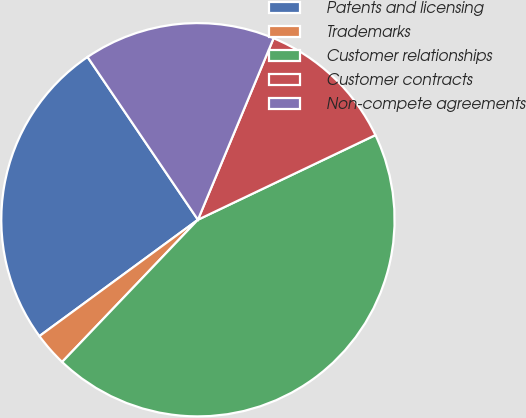<chart> <loc_0><loc_0><loc_500><loc_500><pie_chart><fcel>Patents and licensing<fcel>Trademarks<fcel>Customer relationships<fcel>Customer contracts<fcel>Non-compete agreements<nl><fcel>25.59%<fcel>2.79%<fcel>44.21%<fcel>11.63%<fcel>15.77%<nl></chart> 